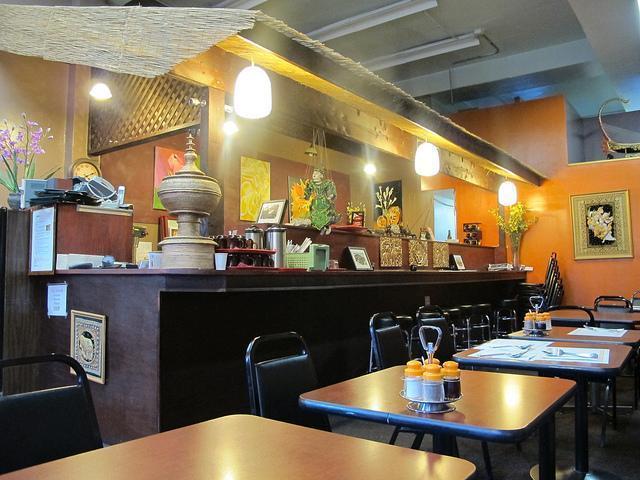How many dining tables are in the picture?
Give a very brief answer. 4. How many chairs can be seen?
Give a very brief answer. 2. 